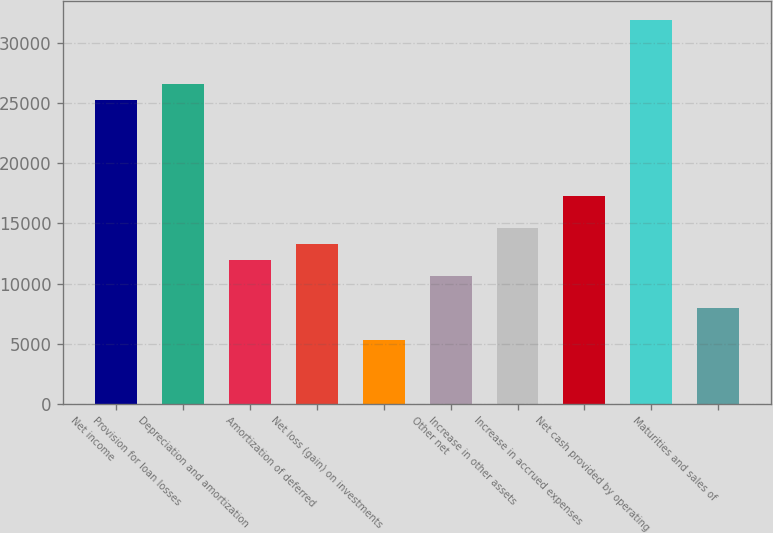<chart> <loc_0><loc_0><loc_500><loc_500><bar_chart><fcel>Net income<fcel>Provision for loan losses<fcel>Depreciation and amortization<fcel>Amortization of deferred<fcel>Net loss (gain) on investments<fcel>Other net<fcel>Increase in other assets<fcel>Increase in accrued expenses<fcel>Net cash provided by operating<fcel>Maturities and sales of<nl><fcel>25276.9<fcel>26607<fcel>11975.9<fcel>13306<fcel>5325.4<fcel>10645.8<fcel>14636.1<fcel>17296.3<fcel>31927.4<fcel>7985.6<nl></chart> 